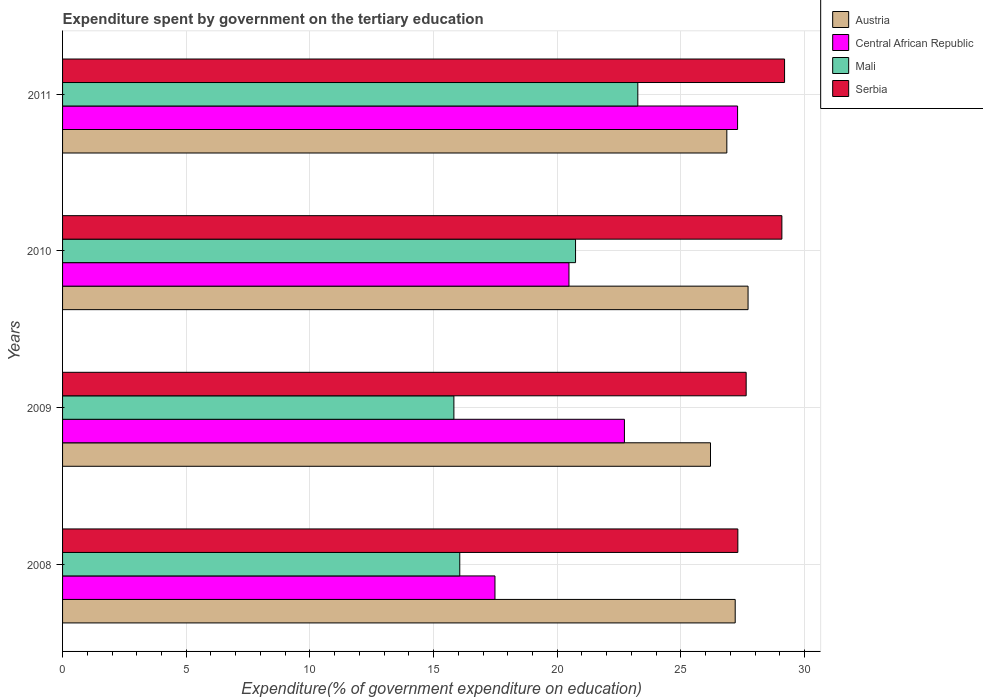Are the number of bars per tick equal to the number of legend labels?
Provide a short and direct response. Yes. How many bars are there on the 3rd tick from the top?
Offer a very short reply. 4. How many bars are there on the 3rd tick from the bottom?
Make the answer very short. 4. What is the label of the 1st group of bars from the top?
Provide a succinct answer. 2011. In how many cases, is the number of bars for a given year not equal to the number of legend labels?
Provide a succinct answer. 0. What is the expenditure spent by government on the tertiary education in Serbia in 2011?
Offer a very short reply. 29.19. Across all years, what is the maximum expenditure spent by government on the tertiary education in Mali?
Provide a short and direct response. 23.26. Across all years, what is the minimum expenditure spent by government on the tertiary education in Serbia?
Ensure brevity in your answer.  27.3. In which year was the expenditure spent by government on the tertiary education in Mali maximum?
Provide a succinct answer. 2011. What is the total expenditure spent by government on the tertiary education in Mali in the graph?
Keep it short and to the point. 75.88. What is the difference between the expenditure spent by government on the tertiary education in Serbia in 2008 and that in 2009?
Keep it short and to the point. -0.34. What is the difference between the expenditure spent by government on the tertiary education in Austria in 2011 and the expenditure spent by government on the tertiary education in Serbia in 2008?
Provide a short and direct response. -0.45. What is the average expenditure spent by government on the tertiary education in Mali per year?
Make the answer very short. 18.97. In the year 2008, what is the difference between the expenditure spent by government on the tertiary education in Mali and expenditure spent by government on the tertiary education in Central African Republic?
Your answer should be compact. -1.42. In how many years, is the expenditure spent by government on the tertiary education in Mali greater than 28 %?
Keep it short and to the point. 0. What is the ratio of the expenditure spent by government on the tertiary education in Serbia in 2009 to that in 2011?
Provide a short and direct response. 0.95. Is the expenditure spent by government on the tertiary education in Serbia in 2009 less than that in 2011?
Keep it short and to the point. Yes. What is the difference between the highest and the second highest expenditure spent by government on the tertiary education in Serbia?
Make the answer very short. 0.11. What is the difference between the highest and the lowest expenditure spent by government on the tertiary education in Central African Republic?
Make the answer very short. 9.81. In how many years, is the expenditure spent by government on the tertiary education in Austria greater than the average expenditure spent by government on the tertiary education in Austria taken over all years?
Give a very brief answer. 2. Is it the case that in every year, the sum of the expenditure spent by government on the tertiary education in Serbia and expenditure spent by government on the tertiary education in Austria is greater than the sum of expenditure spent by government on the tertiary education in Central African Republic and expenditure spent by government on the tertiary education in Mali?
Your answer should be compact. Yes. What does the 2nd bar from the top in 2010 represents?
Ensure brevity in your answer.  Mali. Is it the case that in every year, the sum of the expenditure spent by government on the tertiary education in Central African Republic and expenditure spent by government on the tertiary education in Mali is greater than the expenditure spent by government on the tertiary education in Serbia?
Ensure brevity in your answer.  Yes. How many years are there in the graph?
Keep it short and to the point. 4. What is the difference between two consecutive major ticks on the X-axis?
Make the answer very short. 5. Are the values on the major ticks of X-axis written in scientific E-notation?
Offer a terse response. No. Does the graph contain any zero values?
Provide a succinct answer. No. Where does the legend appear in the graph?
Ensure brevity in your answer.  Top right. How are the legend labels stacked?
Ensure brevity in your answer.  Vertical. What is the title of the graph?
Your answer should be very brief. Expenditure spent by government on the tertiary education. What is the label or title of the X-axis?
Your answer should be very brief. Expenditure(% of government expenditure on education). What is the label or title of the Y-axis?
Provide a succinct answer. Years. What is the Expenditure(% of government expenditure on education) in Austria in 2008?
Offer a terse response. 27.19. What is the Expenditure(% of government expenditure on education) in Central African Republic in 2008?
Provide a short and direct response. 17.48. What is the Expenditure(% of government expenditure on education) of Mali in 2008?
Provide a succinct answer. 16.06. What is the Expenditure(% of government expenditure on education) in Serbia in 2008?
Your answer should be compact. 27.3. What is the Expenditure(% of government expenditure on education) of Austria in 2009?
Keep it short and to the point. 26.2. What is the Expenditure(% of government expenditure on education) in Central African Republic in 2009?
Make the answer very short. 22.72. What is the Expenditure(% of government expenditure on education) in Mali in 2009?
Make the answer very short. 15.82. What is the Expenditure(% of government expenditure on education) in Serbia in 2009?
Your answer should be compact. 27.64. What is the Expenditure(% of government expenditure on education) in Austria in 2010?
Offer a terse response. 27.71. What is the Expenditure(% of government expenditure on education) of Central African Republic in 2010?
Provide a short and direct response. 20.47. What is the Expenditure(% of government expenditure on education) of Mali in 2010?
Keep it short and to the point. 20.74. What is the Expenditure(% of government expenditure on education) of Serbia in 2010?
Provide a short and direct response. 29.08. What is the Expenditure(% of government expenditure on education) of Austria in 2011?
Provide a succinct answer. 26.86. What is the Expenditure(% of government expenditure on education) of Central African Republic in 2011?
Keep it short and to the point. 27.29. What is the Expenditure(% of government expenditure on education) of Mali in 2011?
Your answer should be very brief. 23.26. What is the Expenditure(% of government expenditure on education) in Serbia in 2011?
Offer a very short reply. 29.19. Across all years, what is the maximum Expenditure(% of government expenditure on education) of Austria?
Keep it short and to the point. 27.71. Across all years, what is the maximum Expenditure(% of government expenditure on education) in Central African Republic?
Keep it short and to the point. 27.29. Across all years, what is the maximum Expenditure(% of government expenditure on education) in Mali?
Your response must be concise. 23.26. Across all years, what is the maximum Expenditure(% of government expenditure on education) of Serbia?
Offer a terse response. 29.19. Across all years, what is the minimum Expenditure(% of government expenditure on education) of Austria?
Ensure brevity in your answer.  26.2. Across all years, what is the minimum Expenditure(% of government expenditure on education) of Central African Republic?
Provide a succinct answer. 17.48. Across all years, what is the minimum Expenditure(% of government expenditure on education) in Mali?
Your answer should be very brief. 15.82. Across all years, what is the minimum Expenditure(% of government expenditure on education) in Serbia?
Your answer should be compact. 27.3. What is the total Expenditure(% of government expenditure on education) in Austria in the graph?
Make the answer very short. 107.96. What is the total Expenditure(% of government expenditure on education) in Central African Republic in the graph?
Your response must be concise. 87.96. What is the total Expenditure(% of government expenditure on education) of Mali in the graph?
Keep it short and to the point. 75.88. What is the total Expenditure(% of government expenditure on education) of Serbia in the graph?
Give a very brief answer. 113.21. What is the difference between the Expenditure(% of government expenditure on education) in Austria in 2008 and that in 2009?
Offer a terse response. 1. What is the difference between the Expenditure(% of government expenditure on education) in Central African Republic in 2008 and that in 2009?
Make the answer very short. -5.23. What is the difference between the Expenditure(% of government expenditure on education) of Mali in 2008 and that in 2009?
Provide a short and direct response. 0.24. What is the difference between the Expenditure(% of government expenditure on education) of Serbia in 2008 and that in 2009?
Keep it short and to the point. -0.34. What is the difference between the Expenditure(% of government expenditure on education) of Austria in 2008 and that in 2010?
Offer a very short reply. -0.52. What is the difference between the Expenditure(% of government expenditure on education) in Central African Republic in 2008 and that in 2010?
Your response must be concise. -2.99. What is the difference between the Expenditure(% of government expenditure on education) in Mali in 2008 and that in 2010?
Provide a short and direct response. -4.68. What is the difference between the Expenditure(% of government expenditure on education) of Serbia in 2008 and that in 2010?
Ensure brevity in your answer.  -1.78. What is the difference between the Expenditure(% of government expenditure on education) of Austria in 2008 and that in 2011?
Provide a succinct answer. 0.34. What is the difference between the Expenditure(% of government expenditure on education) of Central African Republic in 2008 and that in 2011?
Your response must be concise. -9.81. What is the difference between the Expenditure(% of government expenditure on education) of Mali in 2008 and that in 2011?
Your response must be concise. -7.2. What is the difference between the Expenditure(% of government expenditure on education) in Serbia in 2008 and that in 2011?
Your answer should be very brief. -1.89. What is the difference between the Expenditure(% of government expenditure on education) in Austria in 2009 and that in 2010?
Provide a succinct answer. -1.52. What is the difference between the Expenditure(% of government expenditure on education) in Central African Republic in 2009 and that in 2010?
Offer a terse response. 2.24. What is the difference between the Expenditure(% of government expenditure on education) in Mali in 2009 and that in 2010?
Ensure brevity in your answer.  -4.92. What is the difference between the Expenditure(% of government expenditure on education) of Serbia in 2009 and that in 2010?
Your answer should be compact. -1.44. What is the difference between the Expenditure(% of government expenditure on education) in Austria in 2009 and that in 2011?
Keep it short and to the point. -0.66. What is the difference between the Expenditure(% of government expenditure on education) in Central African Republic in 2009 and that in 2011?
Your answer should be compact. -4.58. What is the difference between the Expenditure(% of government expenditure on education) of Mali in 2009 and that in 2011?
Your response must be concise. -7.44. What is the difference between the Expenditure(% of government expenditure on education) in Serbia in 2009 and that in 2011?
Your answer should be very brief. -1.55. What is the difference between the Expenditure(% of government expenditure on education) in Austria in 2010 and that in 2011?
Give a very brief answer. 0.86. What is the difference between the Expenditure(% of government expenditure on education) of Central African Republic in 2010 and that in 2011?
Offer a terse response. -6.82. What is the difference between the Expenditure(% of government expenditure on education) in Mali in 2010 and that in 2011?
Ensure brevity in your answer.  -2.52. What is the difference between the Expenditure(% of government expenditure on education) of Serbia in 2010 and that in 2011?
Offer a very short reply. -0.11. What is the difference between the Expenditure(% of government expenditure on education) of Austria in 2008 and the Expenditure(% of government expenditure on education) of Central African Republic in 2009?
Your answer should be compact. 4.48. What is the difference between the Expenditure(% of government expenditure on education) of Austria in 2008 and the Expenditure(% of government expenditure on education) of Mali in 2009?
Offer a terse response. 11.37. What is the difference between the Expenditure(% of government expenditure on education) of Austria in 2008 and the Expenditure(% of government expenditure on education) of Serbia in 2009?
Make the answer very short. -0.44. What is the difference between the Expenditure(% of government expenditure on education) in Central African Republic in 2008 and the Expenditure(% of government expenditure on education) in Mali in 2009?
Give a very brief answer. 1.66. What is the difference between the Expenditure(% of government expenditure on education) in Central African Republic in 2008 and the Expenditure(% of government expenditure on education) in Serbia in 2009?
Your answer should be very brief. -10.16. What is the difference between the Expenditure(% of government expenditure on education) of Mali in 2008 and the Expenditure(% of government expenditure on education) of Serbia in 2009?
Provide a short and direct response. -11.58. What is the difference between the Expenditure(% of government expenditure on education) in Austria in 2008 and the Expenditure(% of government expenditure on education) in Central African Republic in 2010?
Your response must be concise. 6.72. What is the difference between the Expenditure(% of government expenditure on education) in Austria in 2008 and the Expenditure(% of government expenditure on education) in Mali in 2010?
Offer a terse response. 6.45. What is the difference between the Expenditure(% of government expenditure on education) of Austria in 2008 and the Expenditure(% of government expenditure on education) of Serbia in 2010?
Provide a short and direct response. -1.89. What is the difference between the Expenditure(% of government expenditure on education) of Central African Republic in 2008 and the Expenditure(% of government expenditure on education) of Mali in 2010?
Provide a succinct answer. -3.26. What is the difference between the Expenditure(% of government expenditure on education) in Central African Republic in 2008 and the Expenditure(% of government expenditure on education) in Serbia in 2010?
Provide a succinct answer. -11.6. What is the difference between the Expenditure(% of government expenditure on education) of Mali in 2008 and the Expenditure(% of government expenditure on education) of Serbia in 2010?
Offer a terse response. -13.02. What is the difference between the Expenditure(% of government expenditure on education) of Austria in 2008 and the Expenditure(% of government expenditure on education) of Central African Republic in 2011?
Your response must be concise. -0.1. What is the difference between the Expenditure(% of government expenditure on education) of Austria in 2008 and the Expenditure(% of government expenditure on education) of Mali in 2011?
Make the answer very short. 3.94. What is the difference between the Expenditure(% of government expenditure on education) of Austria in 2008 and the Expenditure(% of government expenditure on education) of Serbia in 2011?
Provide a succinct answer. -2. What is the difference between the Expenditure(% of government expenditure on education) in Central African Republic in 2008 and the Expenditure(% of government expenditure on education) in Mali in 2011?
Your answer should be compact. -5.78. What is the difference between the Expenditure(% of government expenditure on education) in Central African Republic in 2008 and the Expenditure(% of government expenditure on education) in Serbia in 2011?
Ensure brevity in your answer.  -11.71. What is the difference between the Expenditure(% of government expenditure on education) of Mali in 2008 and the Expenditure(% of government expenditure on education) of Serbia in 2011?
Make the answer very short. -13.13. What is the difference between the Expenditure(% of government expenditure on education) in Austria in 2009 and the Expenditure(% of government expenditure on education) in Central African Republic in 2010?
Your response must be concise. 5.72. What is the difference between the Expenditure(% of government expenditure on education) of Austria in 2009 and the Expenditure(% of government expenditure on education) of Mali in 2010?
Provide a short and direct response. 5.46. What is the difference between the Expenditure(% of government expenditure on education) of Austria in 2009 and the Expenditure(% of government expenditure on education) of Serbia in 2010?
Give a very brief answer. -2.89. What is the difference between the Expenditure(% of government expenditure on education) of Central African Republic in 2009 and the Expenditure(% of government expenditure on education) of Mali in 2010?
Give a very brief answer. 1.98. What is the difference between the Expenditure(% of government expenditure on education) in Central African Republic in 2009 and the Expenditure(% of government expenditure on education) in Serbia in 2010?
Your response must be concise. -6.37. What is the difference between the Expenditure(% of government expenditure on education) in Mali in 2009 and the Expenditure(% of government expenditure on education) in Serbia in 2010?
Keep it short and to the point. -13.26. What is the difference between the Expenditure(% of government expenditure on education) of Austria in 2009 and the Expenditure(% of government expenditure on education) of Central African Republic in 2011?
Your answer should be very brief. -1.1. What is the difference between the Expenditure(% of government expenditure on education) in Austria in 2009 and the Expenditure(% of government expenditure on education) in Mali in 2011?
Give a very brief answer. 2.94. What is the difference between the Expenditure(% of government expenditure on education) of Austria in 2009 and the Expenditure(% of government expenditure on education) of Serbia in 2011?
Your answer should be compact. -2.99. What is the difference between the Expenditure(% of government expenditure on education) of Central African Republic in 2009 and the Expenditure(% of government expenditure on education) of Mali in 2011?
Offer a terse response. -0.54. What is the difference between the Expenditure(% of government expenditure on education) of Central African Republic in 2009 and the Expenditure(% of government expenditure on education) of Serbia in 2011?
Offer a very short reply. -6.47. What is the difference between the Expenditure(% of government expenditure on education) in Mali in 2009 and the Expenditure(% of government expenditure on education) in Serbia in 2011?
Your answer should be very brief. -13.37. What is the difference between the Expenditure(% of government expenditure on education) of Austria in 2010 and the Expenditure(% of government expenditure on education) of Central African Republic in 2011?
Your answer should be very brief. 0.42. What is the difference between the Expenditure(% of government expenditure on education) in Austria in 2010 and the Expenditure(% of government expenditure on education) in Mali in 2011?
Your response must be concise. 4.46. What is the difference between the Expenditure(% of government expenditure on education) in Austria in 2010 and the Expenditure(% of government expenditure on education) in Serbia in 2011?
Offer a very short reply. -1.48. What is the difference between the Expenditure(% of government expenditure on education) in Central African Republic in 2010 and the Expenditure(% of government expenditure on education) in Mali in 2011?
Make the answer very short. -2.78. What is the difference between the Expenditure(% of government expenditure on education) of Central African Republic in 2010 and the Expenditure(% of government expenditure on education) of Serbia in 2011?
Provide a succinct answer. -8.72. What is the difference between the Expenditure(% of government expenditure on education) in Mali in 2010 and the Expenditure(% of government expenditure on education) in Serbia in 2011?
Offer a terse response. -8.45. What is the average Expenditure(% of government expenditure on education) in Austria per year?
Your answer should be compact. 26.99. What is the average Expenditure(% of government expenditure on education) of Central African Republic per year?
Provide a short and direct response. 21.99. What is the average Expenditure(% of government expenditure on education) of Mali per year?
Provide a short and direct response. 18.97. What is the average Expenditure(% of government expenditure on education) in Serbia per year?
Keep it short and to the point. 28.3. In the year 2008, what is the difference between the Expenditure(% of government expenditure on education) in Austria and Expenditure(% of government expenditure on education) in Central African Republic?
Keep it short and to the point. 9.71. In the year 2008, what is the difference between the Expenditure(% of government expenditure on education) in Austria and Expenditure(% of government expenditure on education) in Mali?
Your answer should be compact. 11.14. In the year 2008, what is the difference between the Expenditure(% of government expenditure on education) in Austria and Expenditure(% of government expenditure on education) in Serbia?
Give a very brief answer. -0.11. In the year 2008, what is the difference between the Expenditure(% of government expenditure on education) in Central African Republic and Expenditure(% of government expenditure on education) in Mali?
Your answer should be compact. 1.42. In the year 2008, what is the difference between the Expenditure(% of government expenditure on education) of Central African Republic and Expenditure(% of government expenditure on education) of Serbia?
Offer a very short reply. -9.82. In the year 2008, what is the difference between the Expenditure(% of government expenditure on education) of Mali and Expenditure(% of government expenditure on education) of Serbia?
Ensure brevity in your answer.  -11.24. In the year 2009, what is the difference between the Expenditure(% of government expenditure on education) in Austria and Expenditure(% of government expenditure on education) in Central African Republic?
Make the answer very short. 3.48. In the year 2009, what is the difference between the Expenditure(% of government expenditure on education) of Austria and Expenditure(% of government expenditure on education) of Mali?
Keep it short and to the point. 10.37. In the year 2009, what is the difference between the Expenditure(% of government expenditure on education) in Austria and Expenditure(% of government expenditure on education) in Serbia?
Make the answer very short. -1.44. In the year 2009, what is the difference between the Expenditure(% of government expenditure on education) of Central African Republic and Expenditure(% of government expenditure on education) of Mali?
Your response must be concise. 6.89. In the year 2009, what is the difference between the Expenditure(% of government expenditure on education) in Central African Republic and Expenditure(% of government expenditure on education) in Serbia?
Provide a short and direct response. -4.92. In the year 2009, what is the difference between the Expenditure(% of government expenditure on education) of Mali and Expenditure(% of government expenditure on education) of Serbia?
Offer a terse response. -11.82. In the year 2010, what is the difference between the Expenditure(% of government expenditure on education) of Austria and Expenditure(% of government expenditure on education) of Central African Republic?
Offer a very short reply. 7.24. In the year 2010, what is the difference between the Expenditure(% of government expenditure on education) of Austria and Expenditure(% of government expenditure on education) of Mali?
Provide a short and direct response. 6.97. In the year 2010, what is the difference between the Expenditure(% of government expenditure on education) in Austria and Expenditure(% of government expenditure on education) in Serbia?
Give a very brief answer. -1.37. In the year 2010, what is the difference between the Expenditure(% of government expenditure on education) in Central African Republic and Expenditure(% of government expenditure on education) in Mali?
Make the answer very short. -0.27. In the year 2010, what is the difference between the Expenditure(% of government expenditure on education) in Central African Republic and Expenditure(% of government expenditure on education) in Serbia?
Ensure brevity in your answer.  -8.61. In the year 2010, what is the difference between the Expenditure(% of government expenditure on education) of Mali and Expenditure(% of government expenditure on education) of Serbia?
Provide a short and direct response. -8.34. In the year 2011, what is the difference between the Expenditure(% of government expenditure on education) of Austria and Expenditure(% of government expenditure on education) of Central African Republic?
Your answer should be very brief. -0.44. In the year 2011, what is the difference between the Expenditure(% of government expenditure on education) in Austria and Expenditure(% of government expenditure on education) in Mali?
Offer a terse response. 3.6. In the year 2011, what is the difference between the Expenditure(% of government expenditure on education) in Austria and Expenditure(% of government expenditure on education) in Serbia?
Your answer should be compact. -2.33. In the year 2011, what is the difference between the Expenditure(% of government expenditure on education) of Central African Republic and Expenditure(% of government expenditure on education) of Mali?
Make the answer very short. 4.03. In the year 2011, what is the difference between the Expenditure(% of government expenditure on education) in Central African Republic and Expenditure(% of government expenditure on education) in Serbia?
Provide a succinct answer. -1.9. In the year 2011, what is the difference between the Expenditure(% of government expenditure on education) of Mali and Expenditure(% of government expenditure on education) of Serbia?
Your response must be concise. -5.93. What is the ratio of the Expenditure(% of government expenditure on education) in Austria in 2008 to that in 2009?
Provide a short and direct response. 1.04. What is the ratio of the Expenditure(% of government expenditure on education) in Central African Republic in 2008 to that in 2009?
Your answer should be compact. 0.77. What is the ratio of the Expenditure(% of government expenditure on education) in Serbia in 2008 to that in 2009?
Offer a terse response. 0.99. What is the ratio of the Expenditure(% of government expenditure on education) in Austria in 2008 to that in 2010?
Give a very brief answer. 0.98. What is the ratio of the Expenditure(% of government expenditure on education) in Central African Republic in 2008 to that in 2010?
Offer a very short reply. 0.85. What is the ratio of the Expenditure(% of government expenditure on education) in Mali in 2008 to that in 2010?
Ensure brevity in your answer.  0.77. What is the ratio of the Expenditure(% of government expenditure on education) in Serbia in 2008 to that in 2010?
Your answer should be compact. 0.94. What is the ratio of the Expenditure(% of government expenditure on education) in Austria in 2008 to that in 2011?
Give a very brief answer. 1.01. What is the ratio of the Expenditure(% of government expenditure on education) of Central African Republic in 2008 to that in 2011?
Your response must be concise. 0.64. What is the ratio of the Expenditure(% of government expenditure on education) of Mali in 2008 to that in 2011?
Provide a short and direct response. 0.69. What is the ratio of the Expenditure(% of government expenditure on education) of Serbia in 2008 to that in 2011?
Offer a terse response. 0.94. What is the ratio of the Expenditure(% of government expenditure on education) in Austria in 2009 to that in 2010?
Offer a very short reply. 0.95. What is the ratio of the Expenditure(% of government expenditure on education) in Central African Republic in 2009 to that in 2010?
Give a very brief answer. 1.11. What is the ratio of the Expenditure(% of government expenditure on education) in Mali in 2009 to that in 2010?
Give a very brief answer. 0.76. What is the ratio of the Expenditure(% of government expenditure on education) in Serbia in 2009 to that in 2010?
Your answer should be very brief. 0.95. What is the ratio of the Expenditure(% of government expenditure on education) of Austria in 2009 to that in 2011?
Offer a terse response. 0.98. What is the ratio of the Expenditure(% of government expenditure on education) in Central African Republic in 2009 to that in 2011?
Give a very brief answer. 0.83. What is the ratio of the Expenditure(% of government expenditure on education) of Mali in 2009 to that in 2011?
Provide a short and direct response. 0.68. What is the ratio of the Expenditure(% of government expenditure on education) of Serbia in 2009 to that in 2011?
Provide a short and direct response. 0.95. What is the ratio of the Expenditure(% of government expenditure on education) of Austria in 2010 to that in 2011?
Your answer should be compact. 1.03. What is the ratio of the Expenditure(% of government expenditure on education) of Central African Republic in 2010 to that in 2011?
Offer a very short reply. 0.75. What is the ratio of the Expenditure(% of government expenditure on education) of Mali in 2010 to that in 2011?
Provide a short and direct response. 0.89. What is the ratio of the Expenditure(% of government expenditure on education) of Serbia in 2010 to that in 2011?
Give a very brief answer. 1. What is the difference between the highest and the second highest Expenditure(% of government expenditure on education) in Austria?
Ensure brevity in your answer.  0.52. What is the difference between the highest and the second highest Expenditure(% of government expenditure on education) in Central African Republic?
Your response must be concise. 4.58. What is the difference between the highest and the second highest Expenditure(% of government expenditure on education) in Mali?
Make the answer very short. 2.52. What is the difference between the highest and the second highest Expenditure(% of government expenditure on education) of Serbia?
Your answer should be very brief. 0.11. What is the difference between the highest and the lowest Expenditure(% of government expenditure on education) of Austria?
Provide a succinct answer. 1.52. What is the difference between the highest and the lowest Expenditure(% of government expenditure on education) of Central African Republic?
Offer a terse response. 9.81. What is the difference between the highest and the lowest Expenditure(% of government expenditure on education) of Mali?
Keep it short and to the point. 7.44. What is the difference between the highest and the lowest Expenditure(% of government expenditure on education) of Serbia?
Your answer should be very brief. 1.89. 